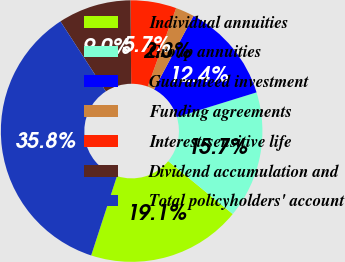Convert chart. <chart><loc_0><loc_0><loc_500><loc_500><pie_chart><fcel>Individual annuities<fcel>Group annuities<fcel>Guaranteed investment<fcel>Funding agreements<fcel>Interest-sensitive life<fcel>Dividend accumulation and<fcel>Total policyholders' account<nl><fcel>19.07%<fcel>15.72%<fcel>12.37%<fcel>2.32%<fcel>5.67%<fcel>9.02%<fcel>35.83%<nl></chart> 